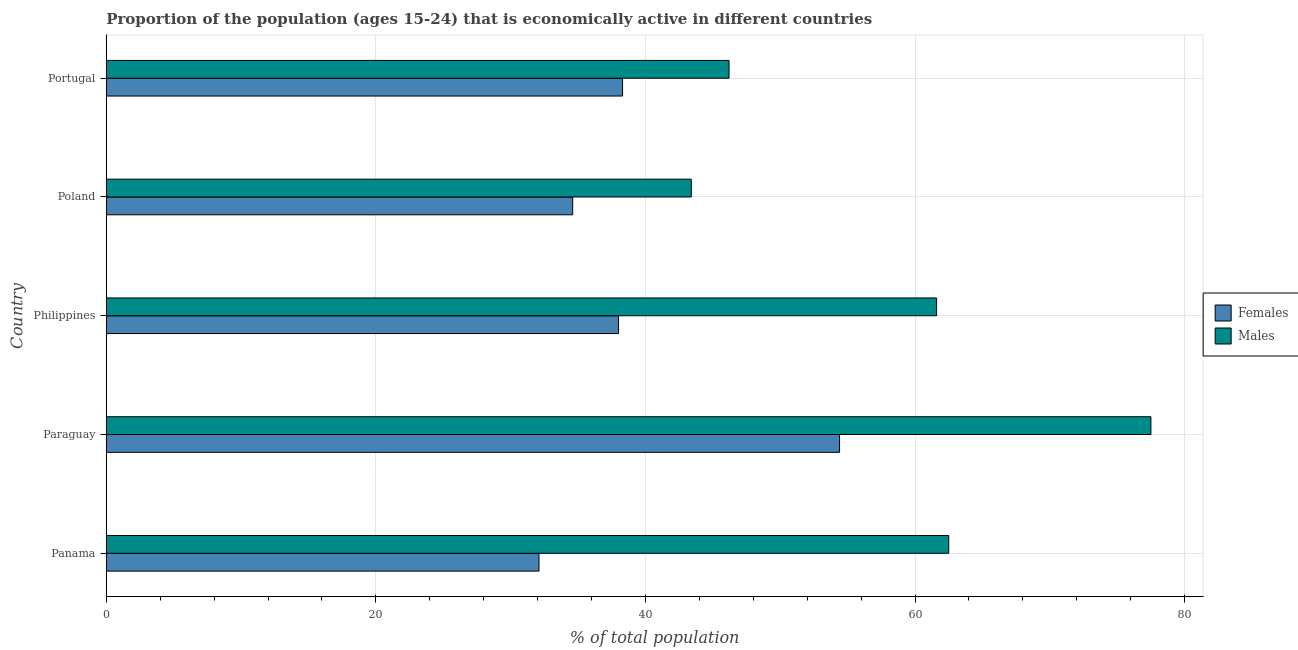What is the label of the 3rd group of bars from the top?
Keep it short and to the point. Philippines. In how many cases, is the number of bars for a given country not equal to the number of legend labels?
Keep it short and to the point. 0. What is the percentage of economically active female population in Paraguay?
Offer a very short reply. 54.4. Across all countries, what is the maximum percentage of economically active male population?
Your answer should be very brief. 77.5. Across all countries, what is the minimum percentage of economically active female population?
Your answer should be very brief. 32.1. In which country was the percentage of economically active male population maximum?
Give a very brief answer. Paraguay. In which country was the percentage of economically active male population minimum?
Your answer should be compact. Poland. What is the total percentage of economically active female population in the graph?
Your response must be concise. 197.4. What is the difference between the percentage of economically active female population in Panama and the percentage of economically active male population in Paraguay?
Your answer should be compact. -45.4. What is the average percentage of economically active male population per country?
Provide a short and direct response. 58.24. What is the difference between the percentage of economically active female population and percentage of economically active male population in Panama?
Offer a very short reply. -30.4. In how many countries, is the percentage of economically active female population greater than 44 %?
Make the answer very short. 1. What is the ratio of the percentage of economically active female population in Panama to that in Poland?
Make the answer very short. 0.93. What is the difference between the highest and the lowest percentage of economically active female population?
Ensure brevity in your answer.  22.3. Is the sum of the percentage of economically active male population in Paraguay and Philippines greater than the maximum percentage of economically active female population across all countries?
Provide a succinct answer. Yes. What does the 1st bar from the top in Philippines represents?
Offer a very short reply. Males. What does the 1st bar from the bottom in Philippines represents?
Your answer should be very brief. Females. How many bars are there?
Offer a terse response. 10. What is the difference between two consecutive major ticks on the X-axis?
Keep it short and to the point. 20. Where does the legend appear in the graph?
Your answer should be very brief. Center right. How many legend labels are there?
Give a very brief answer. 2. What is the title of the graph?
Your answer should be very brief. Proportion of the population (ages 15-24) that is economically active in different countries. Does "Secondary Education" appear as one of the legend labels in the graph?
Keep it short and to the point. No. What is the label or title of the X-axis?
Make the answer very short. % of total population. What is the label or title of the Y-axis?
Offer a very short reply. Country. What is the % of total population of Females in Panama?
Make the answer very short. 32.1. What is the % of total population of Males in Panama?
Offer a very short reply. 62.5. What is the % of total population of Females in Paraguay?
Your answer should be very brief. 54.4. What is the % of total population in Males in Paraguay?
Provide a short and direct response. 77.5. What is the % of total population in Females in Philippines?
Provide a short and direct response. 38. What is the % of total population of Males in Philippines?
Your response must be concise. 61.6. What is the % of total population in Females in Poland?
Keep it short and to the point. 34.6. What is the % of total population of Males in Poland?
Your answer should be very brief. 43.4. What is the % of total population of Females in Portugal?
Make the answer very short. 38.3. What is the % of total population of Males in Portugal?
Your answer should be very brief. 46.2. Across all countries, what is the maximum % of total population of Females?
Your answer should be compact. 54.4. Across all countries, what is the maximum % of total population in Males?
Give a very brief answer. 77.5. Across all countries, what is the minimum % of total population of Females?
Provide a succinct answer. 32.1. Across all countries, what is the minimum % of total population of Males?
Your response must be concise. 43.4. What is the total % of total population of Females in the graph?
Your answer should be very brief. 197.4. What is the total % of total population in Males in the graph?
Your response must be concise. 291.2. What is the difference between the % of total population of Females in Panama and that in Paraguay?
Make the answer very short. -22.3. What is the difference between the % of total population of Males in Panama and that in Paraguay?
Your response must be concise. -15. What is the difference between the % of total population of Males in Panama and that in Poland?
Offer a terse response. 19.1. What is the difference between the % of total population in Females in Paraguay and that in Poland?
Provide a succinct answer. 19.8. What is the difference between the % of total population of Males in Paraguay and that in Poland?
Keep it short and to the point. 34.1. What is the difference between the % of total population of Males in Paraguay and that in Portugal?
Your response must be concise. 31.3. What is the difference between the % of total population of Females in Philippines and that in Poland?
Ensure brevity in your answer.  3.4. What is the difference between the % of total population of Females in Philippines and that in Portugal?
Keep it short and to the point. -0.3. What is the difference between the % of total population in Females in Poland and that in Portugal?
Provide a short and direct response. -3.7. What is the difference between the % of total population of Males in Poland and that in Portugal?
Provide a succinct answer. -2.8. What is the difference between the % of total population of Females in Panama and the % of total population of Males in Paraguay?
Ensure brevity in your answer.  -45.4. What is the difference between the % of total population in Females in Panama and the % of total population in Males in Philippines?
Offer a very short reply. -29.5. What is the difference between the % of total population in Females in Panama and the % of total population in Males in Portugal?
Provide a succinct answer. -14.1. What is the difference between the % of total population in Females in Philippines and the % of total population in Males in Poland?
Your answer should be compact. -5.4. What is the difference between the % of total population in Females in Philippines and the % of total population in Males in Portugal?
Your answer should be compact. -8.2. What is the difference between the % of total population of Females in Poland and the % of total population of Males in Portugal?
Provide a short and direct response. -11.6. What is the average % of total population of Females per country?
Your answer should be compact. 39.48. What is the average % of total population in Males per country?
Your answer should be very brief. 58.24. What is the difference between the % of total population in Females and % of total population in Males in Panama?
Your response must be concise. -30.4. What is the difference between the % of total population of Females and % of total population of Males in Paraguay?
Your answer should be compact. -23.1. What is the difference between the % of total population of Females and % of total population of Males in Philippines?
Provide a short and direct response. -23.6. What is the ratio of the % of total population of Females in Panama to that in Paraguay?
Your answer should be compact. 0.59. What is the ratio of the % of total population in Males in Panama to that in Paraguay?
Your response must be concise. 0.81. What is the ratio of the % of total population of Females in Panama to that in Philippines?
Your response must be concise. 0.84. What is the ratio of the % of total population of Males in Panama to that in Philippines?
Provide a succinct answer. 1.01. What is the ratio of the % of total population of Females in Panama to that in Poland?
Your response must be concise. 0.93. What is the ratio of the % of total population of Males in Panama to that in Poland?
Make the answer very short. 1.44. What is the ratio of the % of total population in Females in Panama to that in Portugal?
Offer a very short reply. 0.84. What is the ratio of the % of total population in Males in Panama to that in Portugal?
Provide a succinct answer. 1.35. What is the ratio of the % of total population of Females in Paraguay to that in Philippines?
Offer a terse response. 1.43. What is the ratio of the % of total population in Males in Paraguay to that in Philippines?
Make the answer very short. 1.26. What is the ratio of the % of total population of Females in Paraguay to that in Poland?
Provide a short and direct response. 1.57. What is the ratio of the % of total population of Males in Paraguay to that in Poland?
Your answer should be compact. 1.79. What is the ratio of the % of total population in Females in Paraguay to that in Portugal?
Offer a terse response. 1.42. What is the ratio of the % of total population in Males in Paraguay to that in Portugal?
Offer a terse response. 1.68. What is the ratio of the % of total population in Females in Philippines to that in Poland?
Provide a short and direct response. 1.1. What is the ratio of the % of total population in Males in Philippines to that in Poland?
Your answer should be compact. 1.42. What is the ratio of the % of total population in Females in Poland to that in Portugal?
Keep it short and to the point. 0.9. What is the ratio of the % of total population of Males in Poland to that in Portugal?
Ensure brevity in your answer.  0.94. What is the difference between the highest and the second highest % of total population of Females?
Your response must be concise. 16.1. What is the difference between the highest and the second highest % of total population of Males?
Keep it short and to the point. 15. What is the difference between the highest and the lowest % of total population in Females?
Keep it short and to the point. 22.3. What is the difference between the highest and the lowest % of total population of Males?
Give a very brief answer. 34.1. 